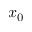Convert formula to latex. <formula><loc_0><loc_0><loc_500><loc_500>x _ { 0 }</formula> 